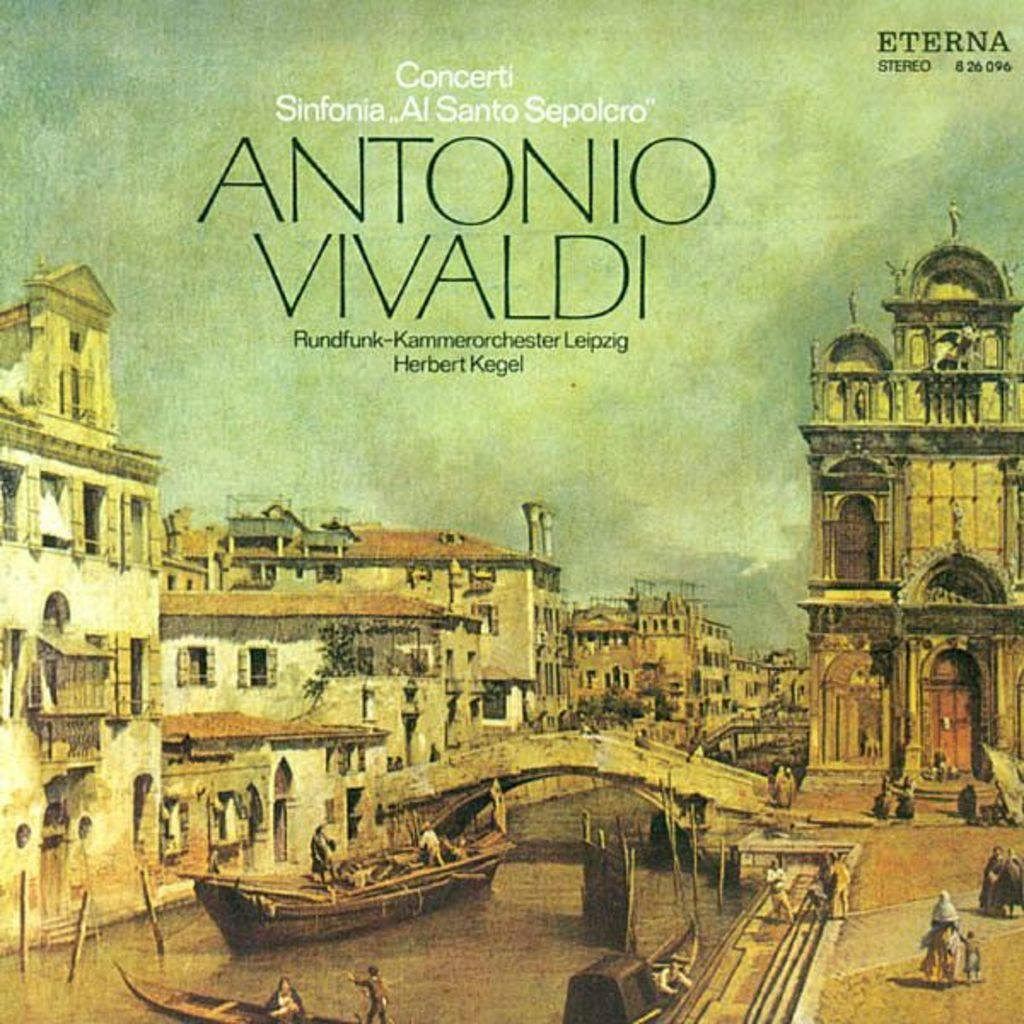<image>
Create a compact narrative representing the image presented. A painting of Venice has the caption Antonio Vivaldi. 